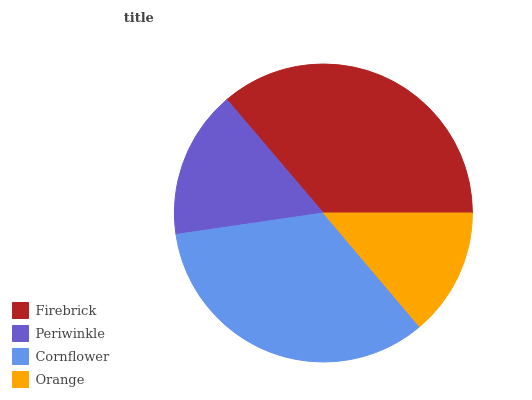Is Orange the minimum?
Answer yes or no. Yes. Is Firebrick the maximum?
Answer yes or no. Yes. Is Periwinkle the minimum?
Answer yes or no. No. Is Periwinkle the maximum?
Answer yes or no. No. Is Firebrick greater than Periwinkle?
Answer yes or no. Yes. Is Periwinkle less than Firebrick?
Answer yes or no. Yes. Is Periwinkle greater than Firebrick?
Answer yes or no. No. Is Firebrick less than Periwinkle?
Answer yes or no. No. Is Cornflower the high median?
Answer yes or no. Yes. Is Periwinkle the low median?
Answer yes or no. Yes. Is Periwinkle the high median?
Answer yes or no. No. Is Firebrick the low median?
Answer yes or no. No. 